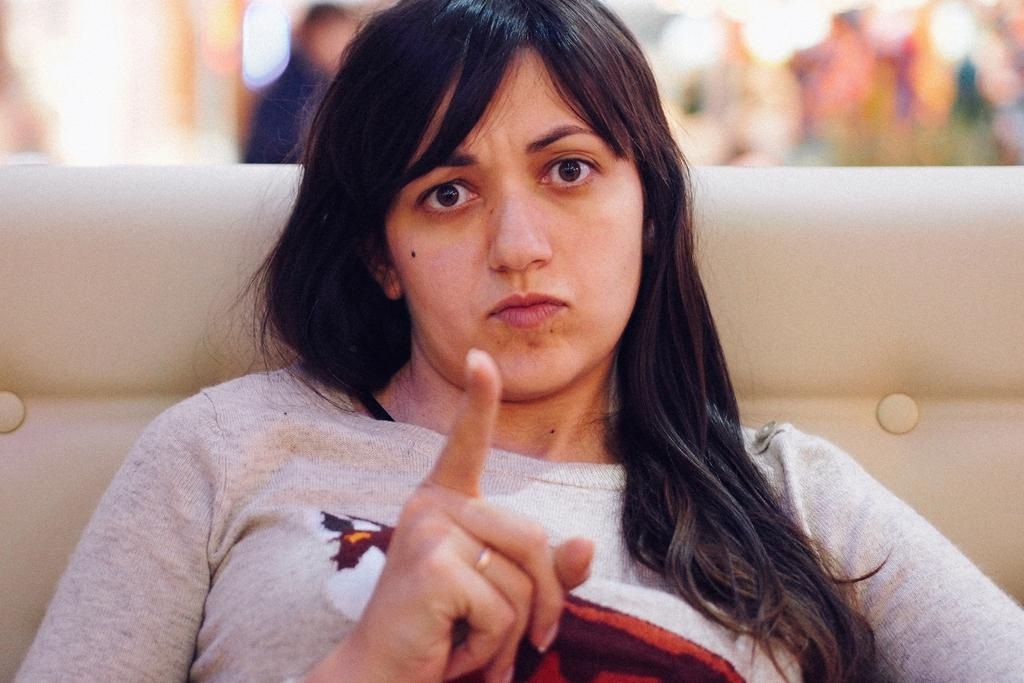Who is the main subject in the image? There is a woman in the image. What is the woman wearing? The woman is wearing a t-shirt. What is the woman's position in the image? The woman is sitting on a couch. Can you describe the man in the background of the image? The man is standing near a wall. What can be seen in the image that provides light? There are lights visible in the image. What is the price of the wooden furniture in the image? There is no wooden furniture present in the image, so it is not possible to determine its price. 